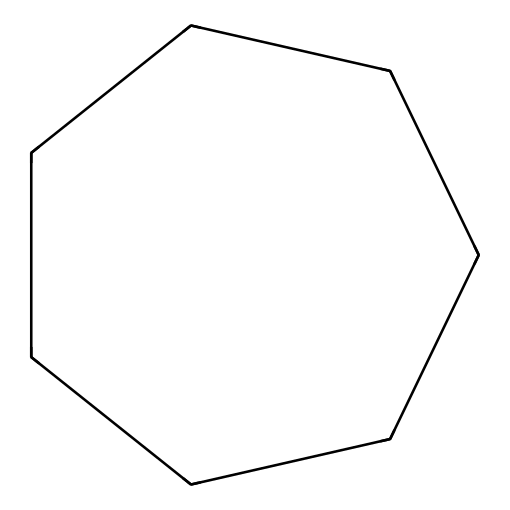What is the molecular formula of cycloheptane? The SMILES representation "C1CCCCCC1" indicates a cyclical structure with seven carbon atoms connected in a ring. Therefore, the molecular formula is based on the count of carbon (C) and hydrogen (H) atoms. For cycloheptane, there are 7 carbon atoms (C) and by using the formula CnH2n, where n is 7, we find that there are 14 hydrogen atoms (H). So, the molecular formula is C7H14.
Answer: C7H14 How many carbon atoms are in cycloheptane? The structure represented in the SMILES shows a cycloalkane with a total of seven carbon atoms connected in a ring, as indicated by the single 'C' repetitions in the format.
Answer: 7 What type of compound is represented by the SMILES 'C1CCCCCC1'? Knowing that the structure has a ring of carbon atoms, this type of compound is classified as a cycloalkane, which contains only carbon and hydrogen atoms and follows the general formula for cycloalkanes.
Answer: cycloalkane What is the degree of saturation for cycloheptane? Cycloheptane is a saturated compound, which has all single bonds in its structure. The degree of saturation can be determined by the formula for cycloalkanes, which indicates that they contain no double or triple bonds. Since every carbon is bonded to hydrogen, it maintains saturation.
Answer: saturated Why is cycloheptane a liquid at room temperature? The molecular structure of cycloheptane, which is a seven-membered ring with a relatively small size, influences its boiling point. The presence of only single bonds allows for flexibility and a more compact structure, resulting in lower intermolecular forces compared to larger hydrocarbons, which typically results in it being a liquid at room temperature.
Answer: liquid How many hydrogen atoms are in cycloheptane? From the molecular formula derived earlier, C7H14 specifies that for cycloheptane, there are 14 hydrogen atoms attached to the seven carbon atoms. This is consistent with the cyclical structure which allows for full saturation with hydrogen.
Answer: 14 